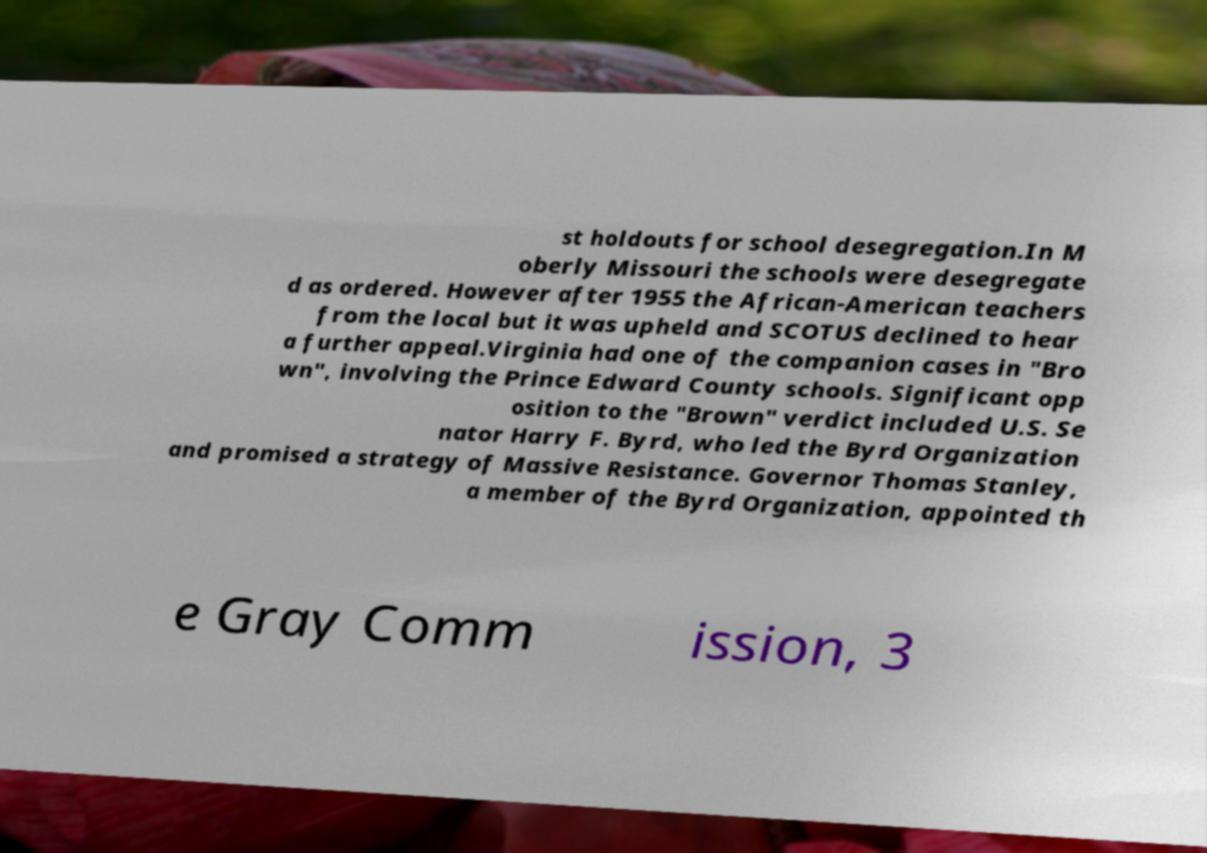There's text embedded in this image that I need extracted. Can you transcribe it verbatim? st holdouts for school desegregation.In M oberly Missouri the schools were desegregate d as ordered. However after 1955 the African-American teachers from the local but it was upheld and SCOTUS declined to hear a further appeal.Virginia had one of the companion cases in "Bro wn", involving the Prince Edward County schools. Significant opp osition to the "Brown" verdict included U.S. Se nator Harry F. Byrd, who led the Byrd Organization and promised a strategy of Massive Resistance. Governor Thomas Stanley, a member of the Byrd Organization, appointed th e Gray Comm ission, 3 